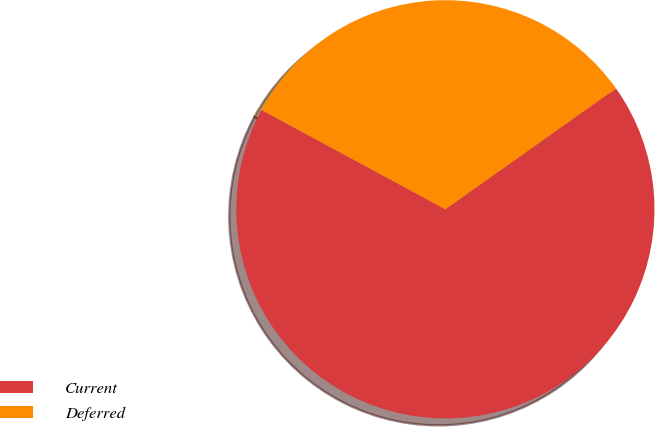Convert chart. <chart><loc_0><loc_0><loc_500><loc_500><pie_chart><fcel>Current<fcel>Deferred<nl><fcel>67.69%<fcel>32.31%<nl></chart> 